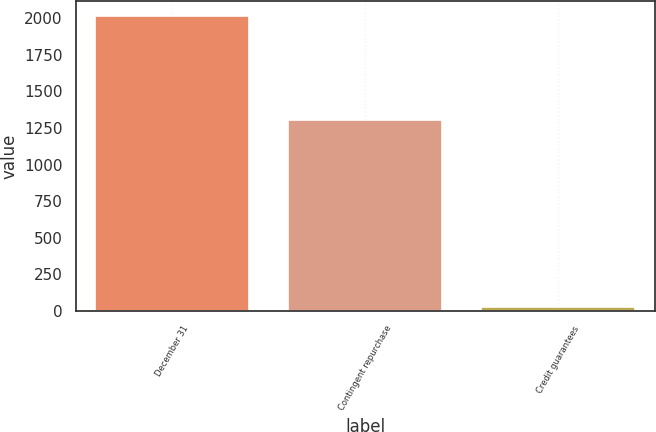Convert chart. <chart><loc_0><loc_0><loc_500><loc_500><bar_chart><fcel>December 31<fcel>Contingent repurchase<fcel>Credit guarantees<nl><fcel>2016<fcel>1306<fcel>29<nl></chart> 